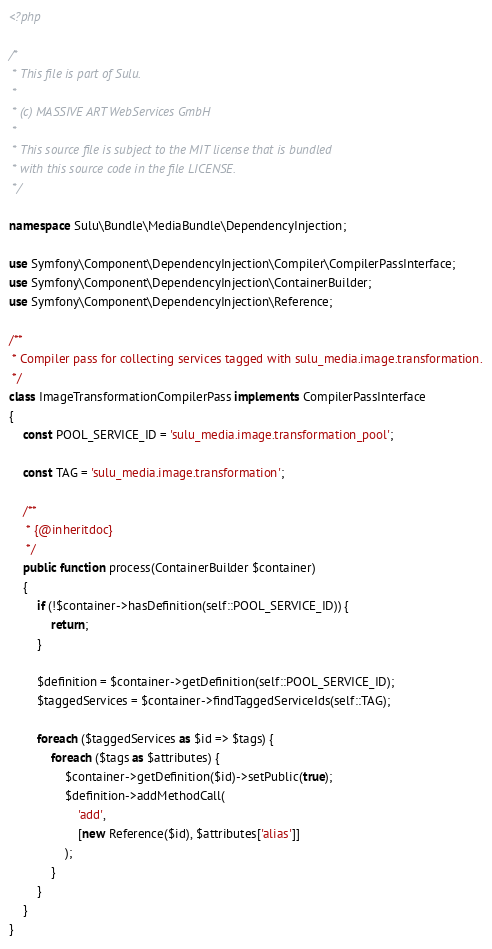<code> <loc_0><loc_0><loc_500><loc_500><_PHP_><?php

/*
 * This file is part of Sulu.
 *
 * (c) MASSIVE ART WebServices GmbH
 *
 * This source file is subject to the MIT license that is bundled
 * with this source code in the file LICENSE.
 */

namespace Sulu\Bundle\MediaBundle\DependencyInjection;

use Symfony\Component\DependencyInjection\Compiler\CompilerPassInterface;
use Symfony\Component\DependencyInjection\ContainerBuilder;
use Symfony\Component\DependencyInjection\Reference;

/**
 * Compiler pass for collecting services tagged with sulu_media.image.transformation.
 */
class ImageTransformationCompilerPass implements CompilerPassInterface
{
    const POOL_SERVICE_ID = 'sulu_media.image.transformation_pool';

    const TAG = 'sulu_media.image.transformation';

    /**
     * {@inheritdoc}
     */
    public function process(ContainerBuilder $container)
    {
        if (!$container->hasDefinition(self::POOL_SERVICE_ID)) {
            return;
        }

        $definition = $container->getDefinition(self::POOL_SERVICE_ID);
        $taggedServices = $container->findTaggedServiceIds(self::TAG);

        foreach ($taggedServices as $id => $tags) {
            foreach ($tags as $attributes) {
                $container->getDefinition($id)->setPublic(true);
                $definition->addMethodCall(
                    'add',
                    [new Reference($id), $attributes['alias']]
                );
            }
        }
    }
}
</code> 